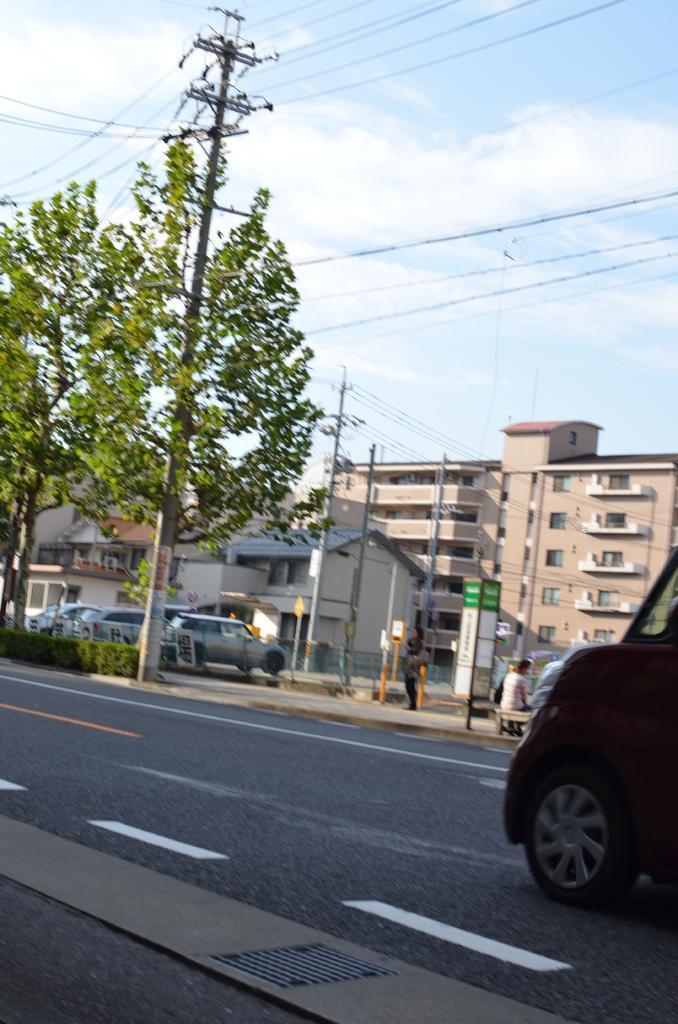Could you give a brief overview of what you see in this image? In this image we can see road on which there is vehicle moving and at the background of the image there are some buildings, persons standing and cars parked and there are some trees and at the top of the image there is clear sky. 